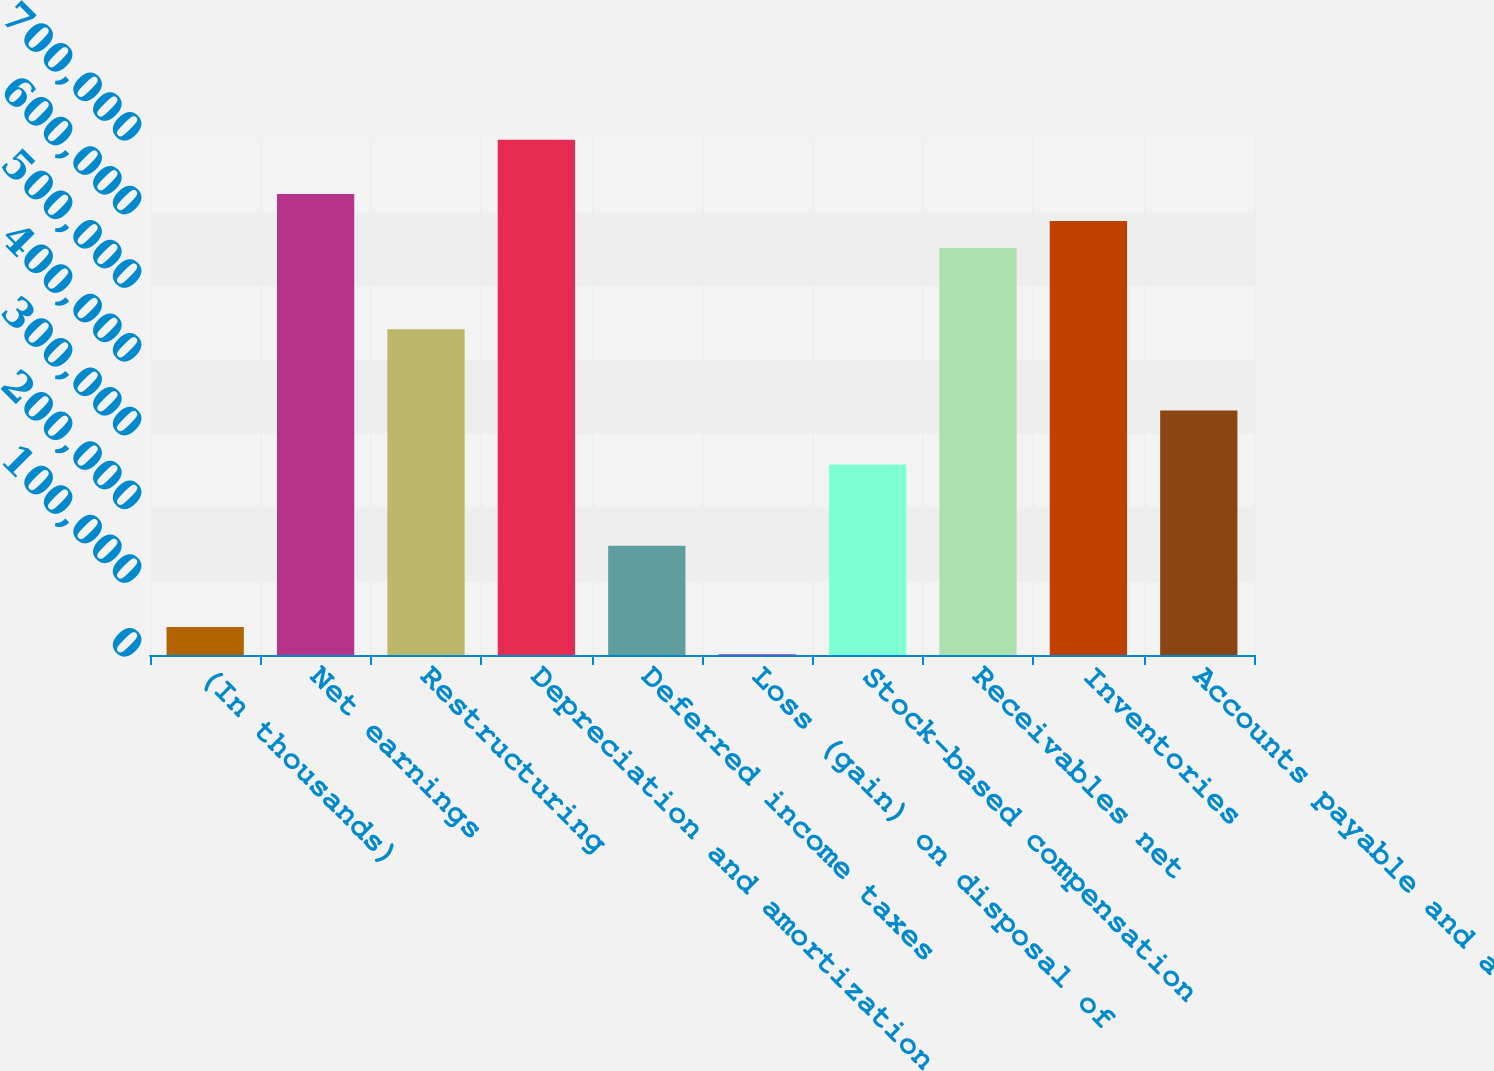<chart> <loc_0><loc_0><loc_500><loc_500><bar_chart><fcel>(In thousands)<fcel>Net earnings<fcel>Restructuring<fcel>Depreciation and amortization<fcel>Deferred income taxes<fcel>Loss (gain) on disposal of<fcel>Stock-based compensation<fcel>Receivables net<fcel>Inventories<fcel>Accounts payable and accrued<nl><fcel>37993.5<fcel>625522<fcel>441919<fcel>698962<fcel>148155<fcel>1273<fcel>258316<fcel>552080<fcel>588801<fcel>331758<nl></chart> 